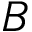<formula> <loc_0><loc_0><loc_500><loc_500>B</formula> 